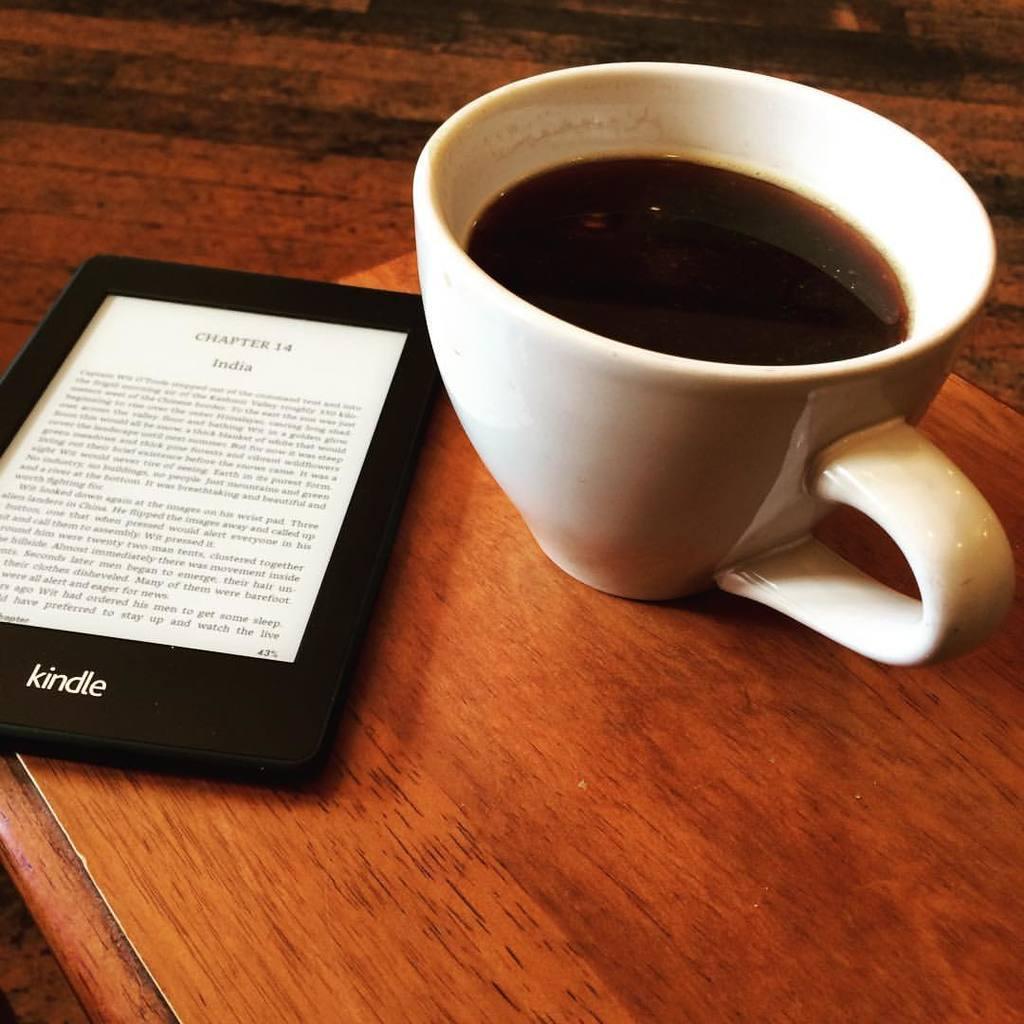Describe this image in one or two sentences. In this image I can see the frame and cup on the brown color table. The frame is in white and black color. I can see the cup with drink and it is also in white color. There is a text written on the frame. 